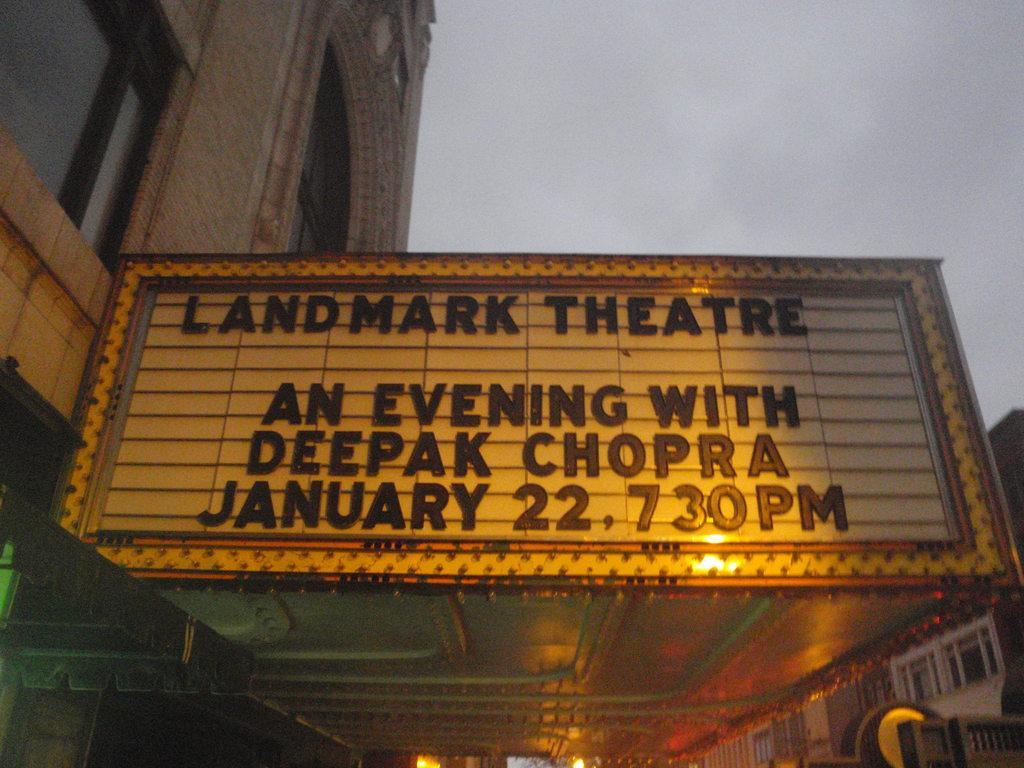In one or two sentences, can you explain what this image depicts? In this picture we can see the theater board on which "Landmark theater" is written. Behind there is a brown building with some glass windows. 